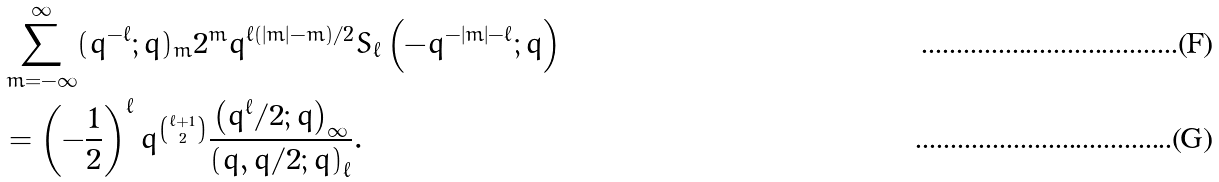Convert formula to latex. <formula><loc_0><loc_0><loc_500><loc_500>& \sum _ { m = - \infty } ^ { \infty } ( q ^ { - \ell } ; q ) _ { m } 2 ^ { m } q ^ { \ell ( | m | - m ) / 2 } S _ { \ell } \left ( - q ^ { - | m | - \ell } ; q \right ) \\ & = \left ( - \frac { 1 } { 2 } \right ) ^ { \ell } q ^ { \binom { \ell + 1 } { 2 } } \frac { \left ( q ^ { \ell } / 2 ; q \right ) _ { \infty } } { \left ( q , q / 2 ; q \right ) _ { \ell } } .</formula> 